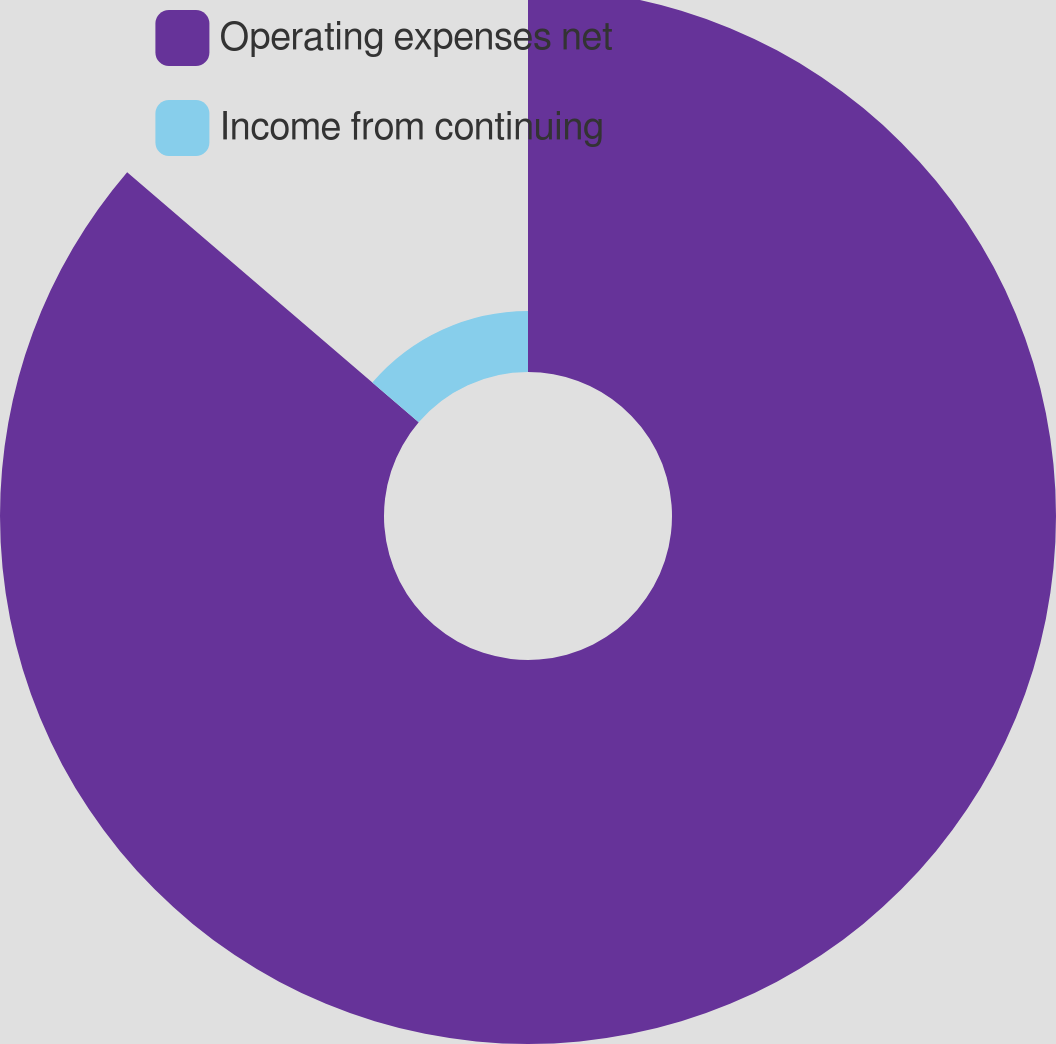Convert chart. <chart><loc_0><loc_0><loc_500><loc_500><pie_chart><fcel>Operating expenses net<fcel>Income from continuing<nl><fcel>86.28%<fcel>13.72%<nl></chart> 